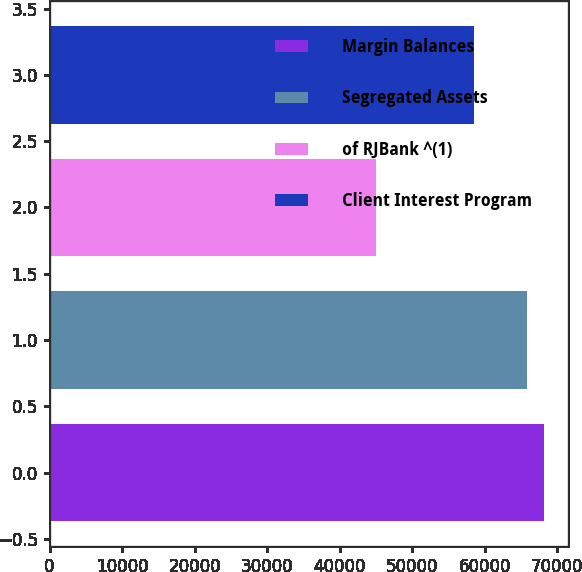<chart> <loc_0><loc_0><loc_500><loc_500><bar_chart><fcel>Margin Balances<fcel>Segregated Assets<fcel>of RJBank ^(1)<fcel>Client Interest Program<nl><fcel>68157.8<fcel>65847<fcel>45017<fcel>58486<nl></chart> 